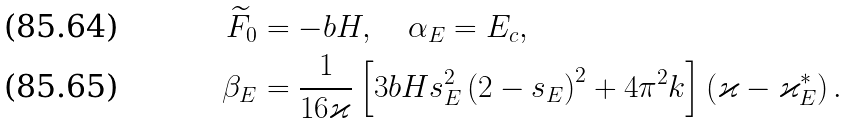<formula> <loc_0><loc_0><loc_500><loc_500>\widetilde { F } _ { 0 } & = - b H , \quad \alpha _ { E } = E _ { c } , \\ \beta _ { E } & = \frac { 1 } { 1 6 \varkappa } \left [ 3 b H s _ { E } ^ { 2 } \left ( 2 - s _ { E } \right ) ^ { 2 } + 4 \pi ^ { 2 } k \right ] \left ( \varkappa - \varkappa _ { E } ^ { * } \right ) .</formula> 